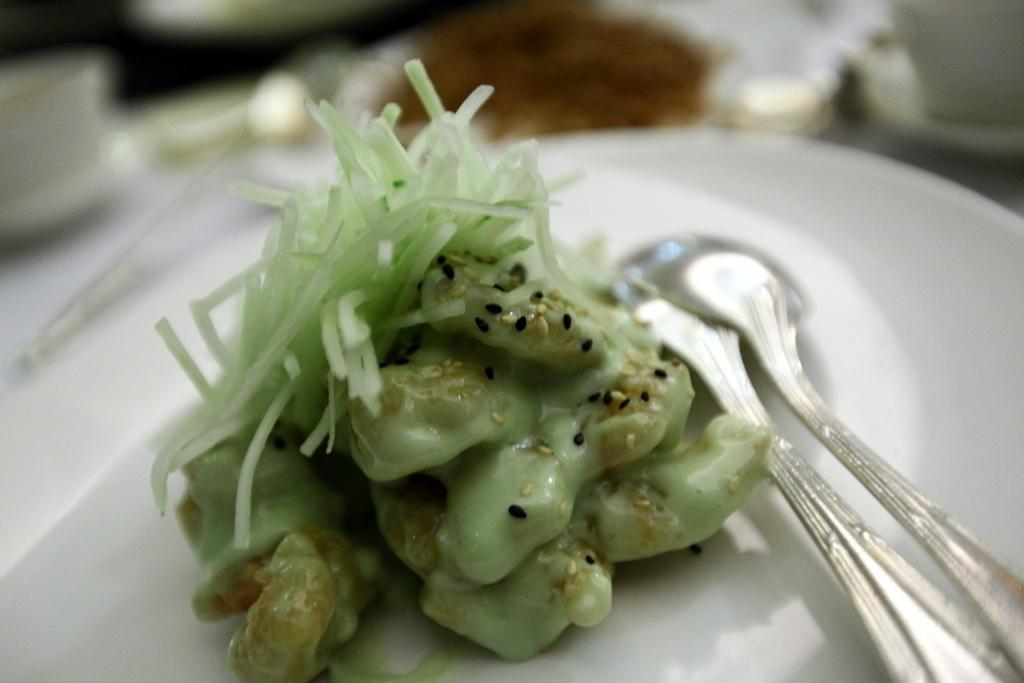What is on the white plate in the image? There is a food item on a white plate in the image. What utensils are present in the image? There is a fork and a spoon in the image. Can you describe the background of the image? The background of the image is blurred. What type of quill is being used to write on the plate in the image? There is no quill present in the image, and the plate is not being used for writing. 